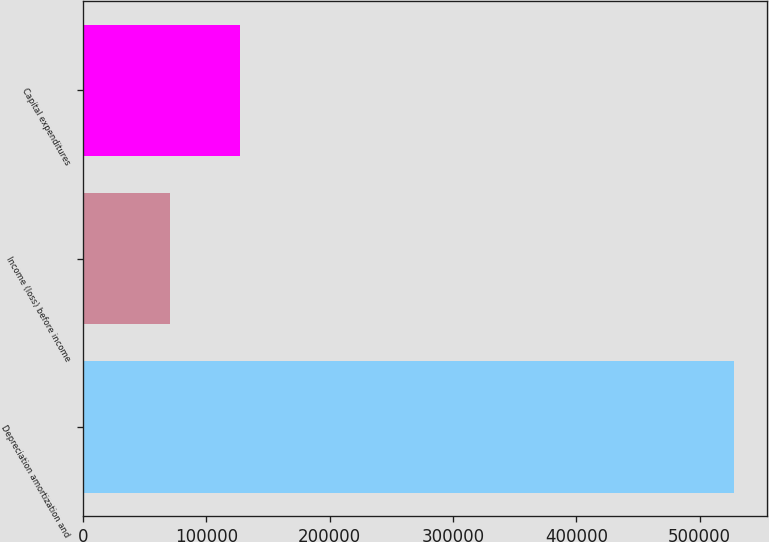<chart> <loc_0><loc_0><loc_500><loc_500><bar_chart><fcel>Depreciation amortization and<fcel>Income (loss) before income<fcel>Capital expenditures<nl><fcel>528051<fcel>70864<fcel>127098<nl></chart> 